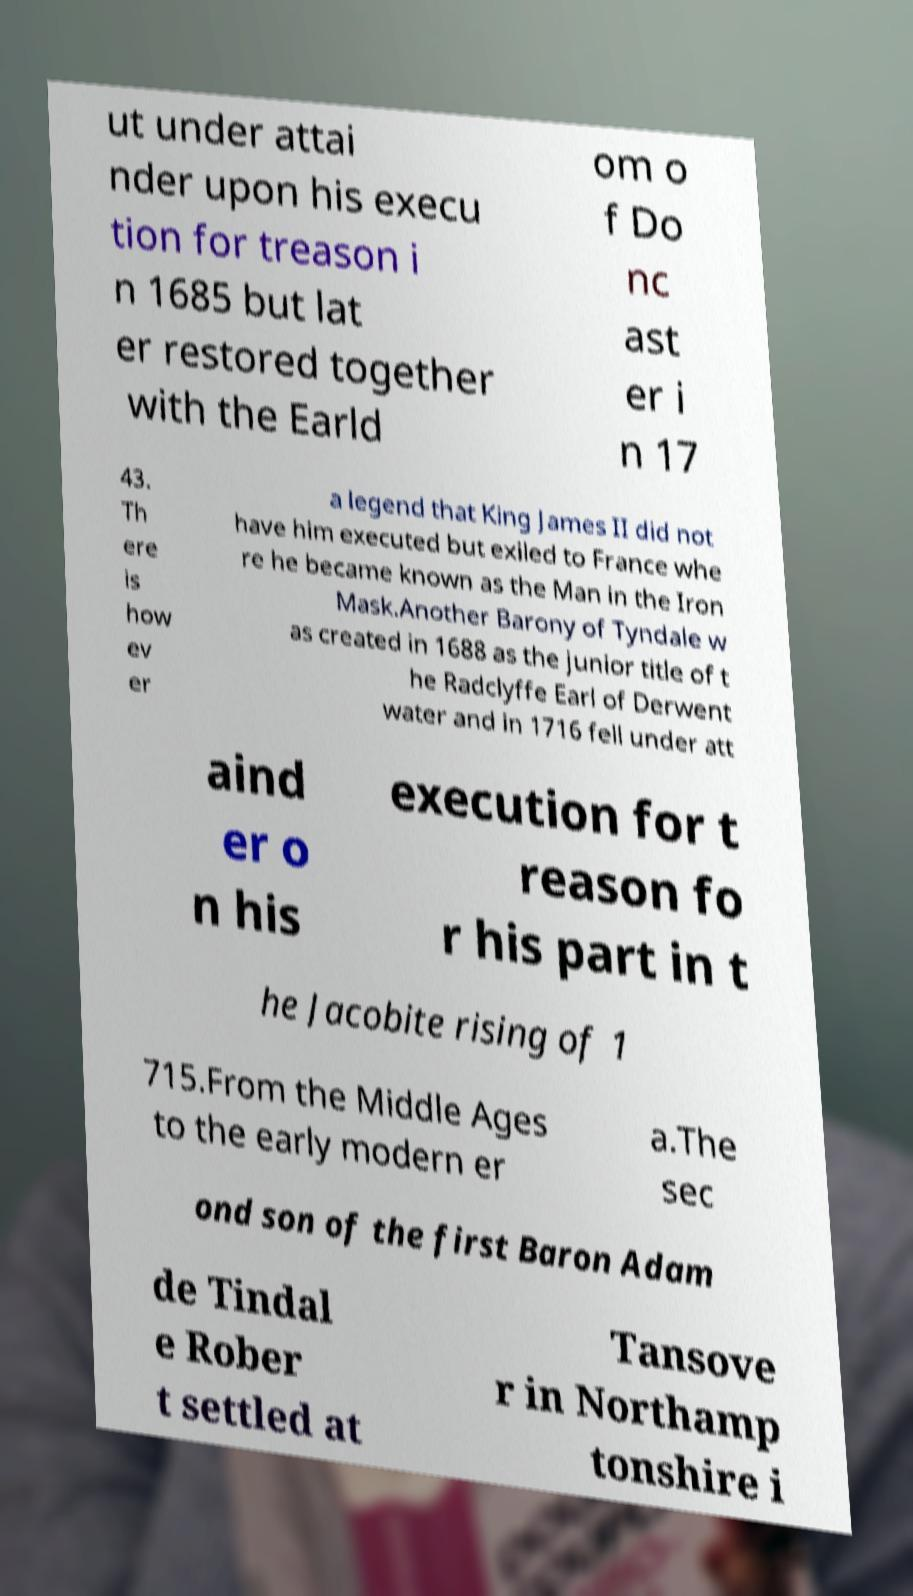Could you extract and type out the text from this image? ut under attai nder upon his execu tion for treason i n 1685 but lat er restored together with the Earld om o f Do nc ast er i n 17 43. Th ere is how ev er a legend that King James II did not have him executed but exiled to France whe re he became known as the Man in the Iron Mask.Another Barony of Tyndale w as created in 1688 as the junior title of t he Radclyffe Earl of Derwent water and in 1716 fell under att aind er o n his execution for t reason fo r his part in t he Jacobite rising of 1 715.From the Middle Ages to the early modern er a.The sec ond son of the first Baron Adam de Tindal e Rober t settled at Tansove r in Northamp tonshire i 